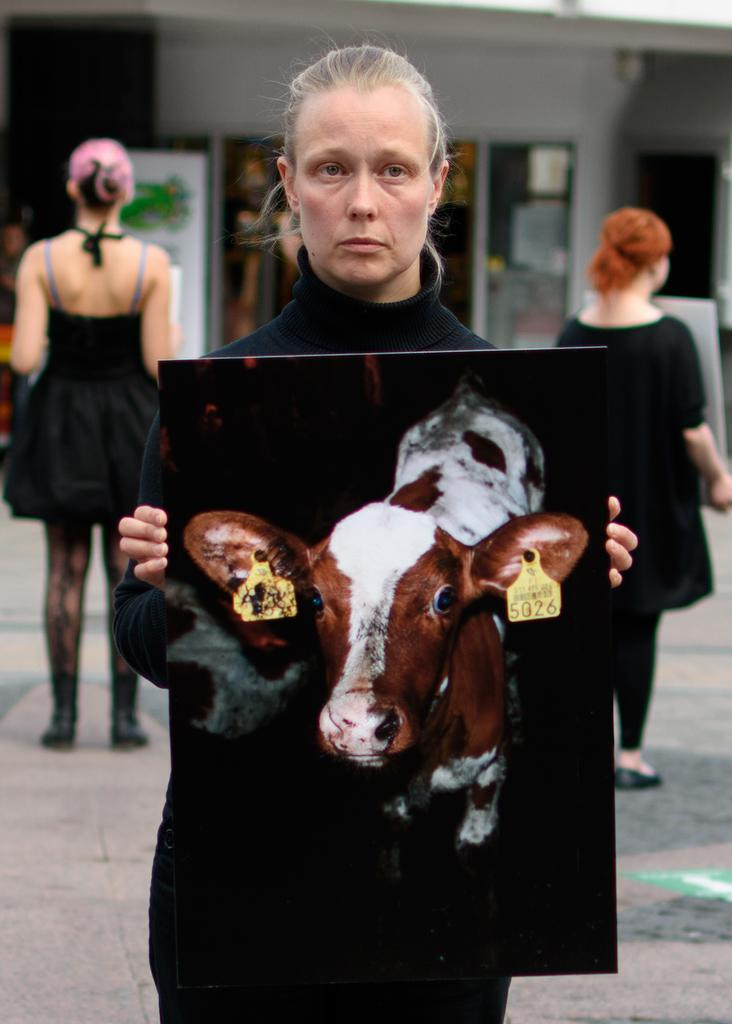Who or what can be seen in the image? There are people in the image. What are the people doing in the image? The people are standing and holding painted boards. What is the price of the car in the image? There is no car present in the image, so it is not possible to determine the price. 